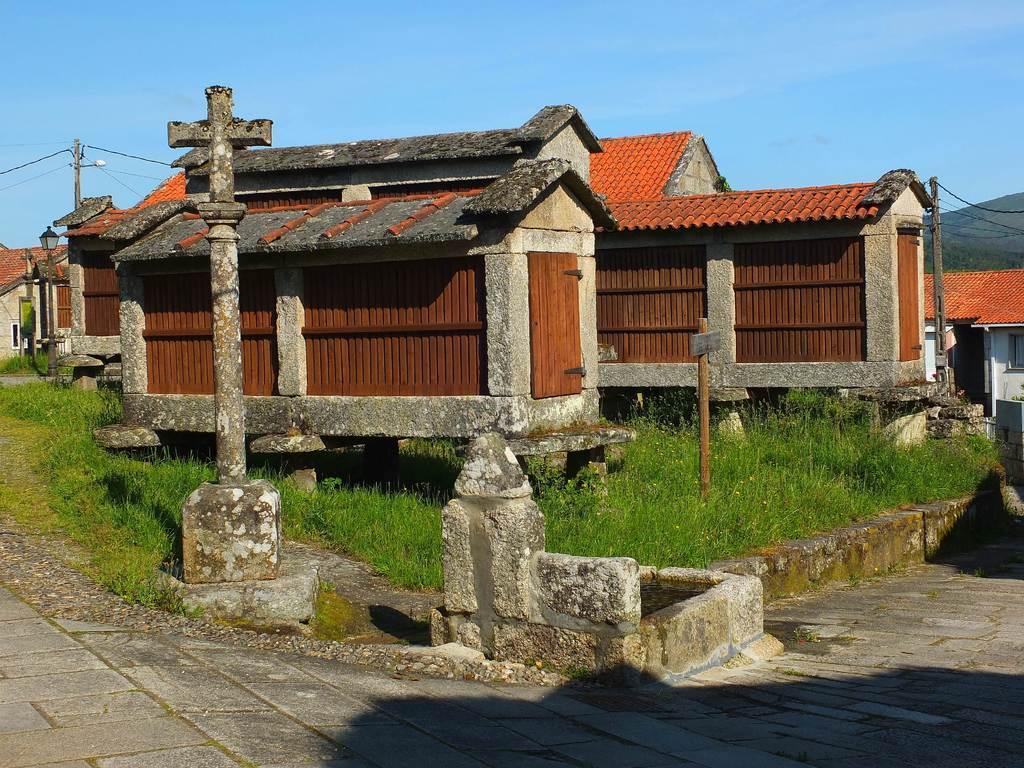Can you describe this image briefly? In this image, we can see few houses, walls, doors, pillar, poles, street light and grass. At the bottom, we can see the walkway. Background we can see the sky, hill and wires. 